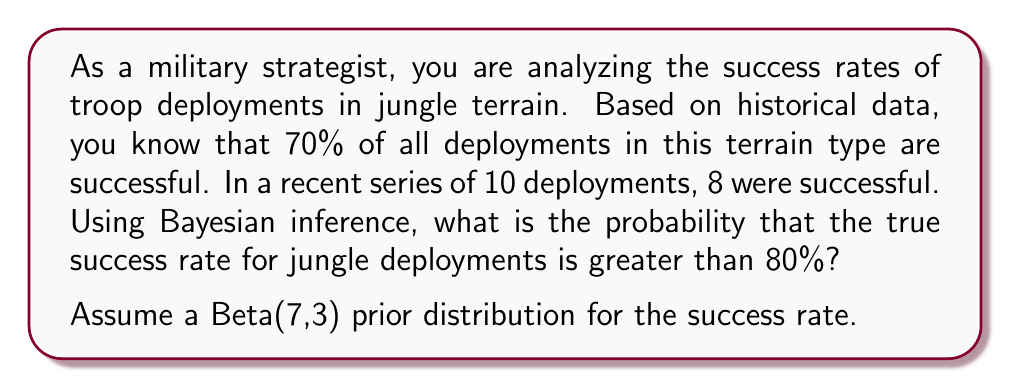Show me your answer to this math problem. To solve this problem, we'll use Bayesian inference with a Beta prior distribution and a Binomial likelihood. Here's the step-by-step solution:

1) We start with a Beta(7,3) prior distribution for the success rate $\theta$. This encodes our prior belief about the success rate.

2) We observe 8 successes out of 10 trials. This is our likelihood, following a Binomial(10,8) distribution.

3) The posterior distribution is also a Beta distribution, with parameters:
   $$\alpha_{posterior} = \alpha_{prior} + \text{successes} = 7 + 8 = 15$$
   $$\beta_{posterior} = \beta_{prior} + \text{failures} = 3 + 2 = 5$$

   So our posterior distribution is Beta(15,5).

4) We want to find $P(\theta > 0.8 | \text{data})$, which is equivalent to finding the area under the Beta(15,5) curve from 0.8 to 1.

5) This probability can be calculated using the incomplete beta function:
   $$P(\theta > 0.8 | \text{data}) = 1 - I_{0.8}(15,5)$$

   Where $I_x(a,b)$ is the regularized incomplete beta function.

6) Using a statistical software or a Beta distribution calculator, we can compute this value:

   $$1 - I_{0.8}(15,5) \approx 0.1959$$

Therefore, the probability that the true success rate for jungle deployments is greater than 80% is approximately 0.1959 or 19.59%.
Answer: 0.1959 (or 19.59%) 